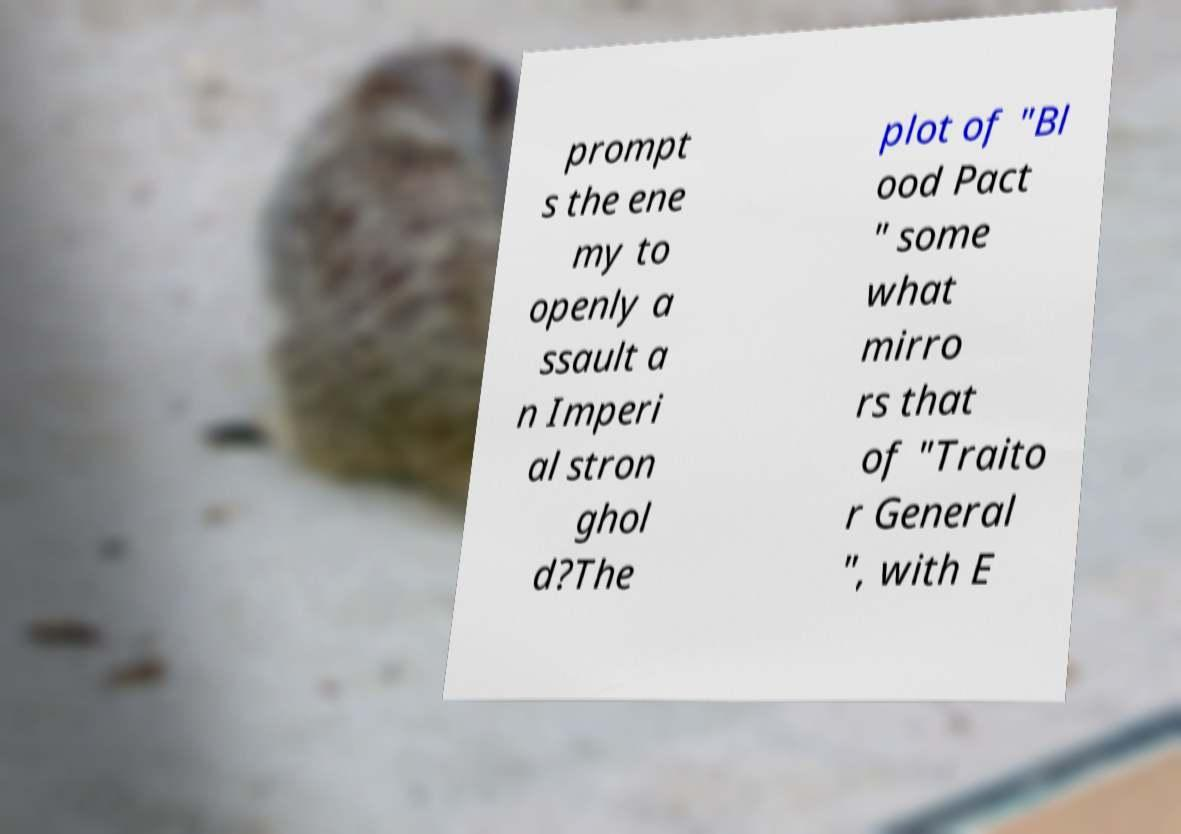I need the written content from this picture converted into text. Can you do that? prompt s the ene my to openly a ssault a n Imperi al stron ghol d?The plot of "Bl ood Pact " some what mirro rs that of "Traito r General ", with E 